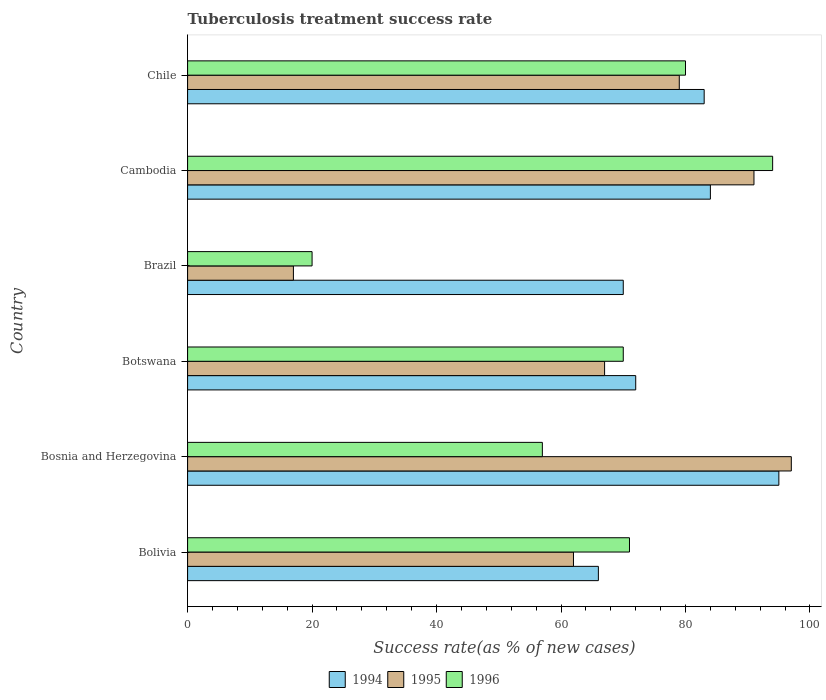How many different coloured bars are there?
Offer a very short reply. 3. How many groups of bars are there?
Offer a terse response. 6. Are the number of bars on each tick of the Y-axis equal?
Keep it short and to the point. Yes. What is the label of the 2nd group of bars from the top?
Offer a very short reply. Cambodia. In how many cases, is the number of bars for a given country not equal to the number of legend labels?
Provide a short and direct response. 0. What is the tuberculosis treatment success rate in 1996 in Cambodia?
Offer a very short reply. 94. Across all countries, what is the maximum tuberculosis treatment success rate in 1995?
Make the answer very short. 97. Across all countries, what is the minimum tuberculosis treatment success rate in 1995?
Ensure brevity in your answer.  17. In which country was the tuberculosis treatment success rate in 1995 maximum?
Your answer should be compact. Bosnia and Herzegovina. In which country was the tuberculosis treatment success rate in 1994 minimum?
Your response must be concise. Bolivia. What is the total tuberculosis treatment success rate in 1995 in the graph?
Keep it short and to the point. 413. What is the difference between the tuberculosis treatment success rate in 1996 in Brazil and that in Chile?
Offer a very short reply. -60. What is the difference between the tuberculosis treatment success rate in 1996 in Bolivia and the tuberculosis treatment success rate in 1995 in Chile?
Offer a terse response. -8. What is the average tuberculosis treatment success rate in 1994 per country?
Your answer should be very brief. 78.33. What is the difference between the tuberculosis treatment success rate in 1994 and tuberculosis treatment success rate in 1996 in Bolivia?
Provide a succinct answer. -5. In how many countries, is the tuberculosis treatment success rate in 1994 greater than 52 %?
Your response must be concise. 6. What is the ratio of the tuberculosis treatment success rate in 1994 in Botswana to that in Brazil?
Give a very brief answer. 1.03. Is the tuberculosis treatment success rate in 1994 in Bosnia and Herzegovina less than that in Botswana?
Make the answer very short. No. Is the difference between the tuberculosis treatment success rate in 1994 in Botswana and Brazil greater than the difference between the tuberculosis treatment success rate in 1996 in Botswana and Brazil?
Your answer should be very brief. No. Is the sum of the tuberculosis treatment success rate in 1995 in Brazil and Chile greater than the maximum tuberculosis treatment success rate in 1996 across all countries?
Your response must be concise. Yes. What does the 1st bar from the top in Brazil represents?
Offer a very short reply. 1996. What does the 3rd bar from the bottom in Bolivia represents?
Offer a terse response. 1996. How many bars are there?
Provide a succinct answer. 18. Are the values on the major ticks of X-axis written in scientific E-notation?
Provide a succinct answer. No. What is the title of the graph?
Offer a very short reply. Tuberculosis treatment success rate. Does "2002" appear as one of the legend labels in the graph?
Keep it short and to the point. No. What is the label or title of the X-axis?
Your response must be concise. Success rate(as % of new cases). What is the Success rate(as % of new cases) of 1994 in Bolivia?
Your answer should be compact. 66. What is the Success rate(as % of new cases) in 1995 in Bolivia?
Provide a short and direct response. 62. What is the Success rate(as % of new cases) in 1994 in Bosnia and Herzegovina?
Your answer should be compact. 95. What is the Success rate(as % of new cases) of 1995 in Bosnia and Herzegovina?
Provide a succinct answer. 97. What is the Success rate(as % of new cases) in 1996 in Botswana?
Offer a terse response. 70. What is the Success rate(as % of new cases) of 1995 in Brazil?
Give a very brief answer. 17. What is the Success rate(as % of new cases) of 1996 in Brazil?
Ensure brevity in your answer.  20. What is the Success rate(as % of new cases) of 1995 in Cambodia?
Provide a short and direct response. 91. What is the Success rate(as % of new cases) in 1996 in Cambodia?
Give a very brief answer. 94. What is the Success rate(as % of new cases) of 1994 in Chile?
Provide a succinct answer. 83. What is the Success rate(as % of new cases) of 1995 in Chile?
Your answer should be compact. 79. What is the Success rate(as % of new cases) of 1996 in Chile?
Your answer should be compact. 80. Across all countries, what is the maximum Success rate(as % of new cases) of 1994?
Ensure brevity in your answer.  95. Across all countries, what is the maximum Success rate(as % of new cases) of 1995?
Offer a very short reply. 97. Across all countries, what is the maximum Success rate(as % of new cases) in 1996?
Give a very brief answer. 94. Across all countries, what is the minimum Success rate(as % of new cases) in 1995?
Make the answer very short. 17. What is the total Success rate(as % of new cases) in 1994 in the graph?
Give a very brief answer. 470. What is the total Success rate(as % of new cases) of 1995 in the graph?
Provide a short and direct response. 413. What is the total Success rate(as % of new cases) of 1996 in the graph?
Your answer should be very brief. 392. What is the difference between the Success rate(as % of new cases) in 1994 in Bolivia and that in Bosnia and Herzegovina?
Your answer should be very brief. -29. What is the difference between the Success rate(as % of new cases) of 1995 in Bolivia and that in Bosnia and Herzegovina?
Your response must be concise. -35. What is the difference between the Success rate(as % of new cases) in 1995 in Bolivia and that in Brazil?
Your answer should be compact. 45. What is the difference between the Success rate(as % of new cases) of 1996 in Bolivia and that in Brazil?
Offer a very short reply. 51. What is the difference between the Success rate(as % of new cases) of 1996 in Bolivia and that in Cambodia?
Your answer should be compact. -23. What is the difference between the Success rate(as % of new cases) of 1996 in Bolivia and that in Chile?
Provide a short and direct response. -9. What is the difference between the Success rate(as % of new cases) of 1995 in Bosnia and Herzegovina and that in Botswana?
Your response must be concise. 30. What is the difference between the Success rate(as % of new cases) of 1994 in Bosnia and Herzegovina and that in Brazil?
Make the answer very short. 25. What is the difference between the Success rate(as % of new cases) of 1995 in Bosnia and Herzegovina and that in Brazil?
Make the answer very short. 80. What is the difference between the Success rate(as % of new cases) of 1994 in Bosnia and Herzegovina and that in Cambodia?
Your answer should be very brief. 11. What is the difference between the Success rate(as % of new cases) of 1996 in Bosnia and Herzegovina and that in Cambodia?
Your response must be concise. -37. What is the difference between the Success rate(as % of new cases) in 1994 in Bosnia and Herzegovina and that in Chile?
Provide a short and direct response. 12. What is the difference between the Success rate(as % of new cases) of 1995 in Bosnia and Herzegovina and that in Chile?
Your answer should be compact. 18. What is the difference between the Success rate(as % of new cases) in 1996 in Bosnia and Herzegovina and that in Chile?
Offer a terse response. -23. What is the difference between the Success rate(as % of new cases) in 1995 in Botswana and that in Brazil?
Offer a very short reply. 50. What is the difference between the Success rate(as % of new cases) of 1995 in Botswana and that in Cambodia?
Make the answer very short. -24. What is the difference between the Success rate(as % of new cases) in 1996 in Botswana and that in Cambodia?
Keep it short and to the point. -24. What is the difference between the Success rate(as % of new cases) in 1994 in Botswana and that in Chile?
Keep it short and to the point. -11. What is the difference between the Success rate(as % of new cases) in 1995 in Botswana and that in Chile?
Ensure brevity in your answer.  -12. What is the difference between the Success rate(as % of new cases) in 1994 in Brazil and that in Cambodia?
Your response must be concise. -14. What is the difference between the Success rate(as % of new cases) in 1995 in Brazil and that in Cambodia?
Make the answer very short. -74. What is the difference between the Success rate(as % of new cases) in 1996 in Brazil and that in Cambodia?
Offer a very short reply. -74. What is the difference between the Success rate(as % of new cases) in 1995 in Brazil and that in Chile?
Give a very brief answer. -62. What is the difference between the Success rate(as % of new cases) of 1996 in Brazil and that in Chile?
Provide a short and direct response. -60. What is the difference between the Success rate(as % of new cases) in 1996 in Cambodia and that in Chile?
Ensure brevity in your answer.  14. What is the difference between the Success rate(as % of new cases) of 1994 in Bolivia and the Success rate(as % of new cases) of 1995 in Bosnia and Herzegovina?
Keep it short and to the point. -31. What is the difference between the Success rate(as % of new cases) in 1994 in Bolivia and the Success rate(as % of new cases) in 1996 in Bosnia and Herzegovina?
Provide a short and direct response. 9. What is the difference between the Success rate(as % of new cases) of 1995 in Bolivia and the Success rate(as % of new cases) of 1996 in Bosnia and Herzegovina?
Ensure brevity in your answer.  5. What is the difference between the Success rate(as % of new cases) in 1994 in Bolivia and the Success rate(as % of new cases) in 1995 in Botswana?
Make the answer very short. -1. What is the difference between the Success rate(as % of new cases) of 1995 in Bolivia and the Success rate(as % of new cases) of 1996 in Botswana?
Provide a short and direct response. -8. What is the difference between the Success rate(as % of new cases) in 1994 in Bolivia and the Success rate(as % of new cases) in 1995 in Brazil?
Provide a succinct answer. 49. What is the difference between the Success rate(as % of new cases) in 1995 in Bolivia and the Success rate(as % of new cases) in 1996 in Brazil?
Ensure brevity in your answer.  42. What is the difference between the Success rate(as % of new cases) in 1994 in Bolivia and the Success rate(as % of new cases) in 1996 in Cambodia?
Ensure brevity in your answer.  -28. What is the difference between the Success rate(as % of new cases) in 1995 in Bolivia and the Success rate(as % of new cases) in 1996 in Cambodia?
Ensure brevity in your answer.  -32. What is the difference between the Success rate(as % of new cases) of 1994 in Bolivia and the Success rate(as % of new cases) of 1995 in Chile?
Ensure brevity in your answer.  -13. What is the difference between the Success rate(as % of new cases) in 1994 in Bosnia and Herzegovina and the Success rate(as % of new cases) in 1996 in Brazil?
Make the answer very short. 75. What is the difference between the Success rate(as % of new cases) in 1995 in Bosnia and Herzegovina and the Success rate(as % of new cases) in 1996 in Brazil?
Provide a short and direct response. 77. What is the difference between the Success rate(as % of new cases) in 1994 in Bosnia and Herzegovina and the Success rate(as % of new cases) in 1995 in Cambodia?
Offer a terse response. 4. What is the difference between the Success rate(as % of new cases) in 1994 in Bosnia and Herzegovina and the Success rate(as % of new cases) in 1996 in Cambodia?
Your answer should be compact. 1. What is the difference between the Success rate(as % of new cases) in 1995 in Bosnia and Herzegovina and the Success rate(as % of new cases) in 1996 in Cambodia?
Give a very brief answer. 3. What is the difference between the Success rate(as % of new cases) of 1994 in Bosnia and Herzegovina and the Success rate(as % of new cases) of 1995 in Chile?
Make the answer very short. 16. What is the difference between the Success rate(as % of new cases) of 1994 in Bosnia and Herzegovina and the Success rate(as % of new cases) of 1996 in Chile?
Keep it short and to the point. 15. What is the difference between the Success rate(as % of new cases) of 1995 in Bosnia and Herzegovina and the Success rate(as % of new cases) of 1996 in Chile?
Give a very brief answer. 17. What is the difference between the Success rate(as % of new cases) in 1994 in Botswana and the Success rate(as % of new cases) in 1996 in Brazil?
Offer a terse response. 52. What is the difference between the Success rate(as % of new cases) of 1995 in Botswana and the Success rate(as % of new cases) of 1996 in Brazil?
Your response must be concise. 47. What is the difference between the Success rate(as % of new cases) of 1994 in Botswana and the Success rate(as % of new cases) of 1995 in Cambodia?
Provide a short and direct response. -19. What is the difference between the Success rate(as % of new cases) in 1994 in Botswana and the Success rate(as % of new cases) in 1996 in Cambodia?
Your answer should be compact. -22. What is the difference between the Success rate(as % of new cases) in 1995 in Botswana and the Success rate(as % of new cases) in 1996 in Cambodia?
Offer a very short reply. -27. What is the difference between the Success rate(as % of new cases) in 1995 in Botswana and the Success rate(as % of new cases) in 1996 in Chile?
Offer a terse response. -13. What is the difference between the Success rate(as % of new cases) in 1994 in Brazil and the Success rate(as % of new cases) in 1995 in Cambodia?
Provide a short and direct response. -21. What is the difference between the Success rate(as % of new cases) of 1995 in Brazil and the Success rate(as % of new cases) of 1996 in Cambodia?
Your answer should be compact. -77. What is the difference between the Success rate(as % of new cases) of 1994 in Brazil and the Success rate(as % of new cases) of 1995 in Chile?
Offer a very short reply. -9. What is the difference between the Success rate(as % of new cases) of 1995 in Brazil and the Success rate(as % of new cases) of 1996 in Chile?
Your answer should be compact. -63. What is the difference between the Success rate(as % of new cases) in 1994 in Cambodia and the Success rate(as % of new cases) in 1996 in Chile?
Provide a short and direct response. 4. What is the average Success rate(as % of new cases) in 1994 per country?
Ensure brevity in your answer.  78.33. What is the average Success rate(as % of new cases) of 1995 per country?
Provide a succinct answer. 68.83. What is the average Success rate(as % of new cases) of 1996 per country?
Provide a succinct answer. 65.33. What is the difference between the Success rate(as % of new cases) of 1994 and Success rate(as % of new cases) of 1996 in Bolivia?
Offer a terse response. -5. What is the difference between the Success rate(as % of new cases) in 1995 and Success rate(as % of new cases) in 1996 in Bolivia?
Your answer should be compact. -9. What is the difference between the Success rate(as % of new cases) in 1994 and Success rate(as % of new cases) in 1995 in Botswana?
Offer a terse response. 5. What is the difference between the Success rate(as % of new cases) in 1994 and Success rate(as % of new cases) in 1996 in Botswana?
Your response must be concise. 2. What is the difference between the Success rate(as % of new cases) of 1995 and Success rate(as % of new cases) of 1996 in Botswana?
Provide a short and direct response. -3. What is the difference between the Success rate(as % of new cases) in 1995 and Success rate(as % of new cases) in 1996 in Brazil?
Give a very brief answer. -3. What is the difference between the Success rate(as % of new cases) in 1994 and Success rate(as % of new cases) in 1996 in Cambodia?
Provide a succinct answer. -10. What is the difference between the Success rate(as % of new cases) in 1995 and Success rate(as % of new cases) in 1996 in Cambodia?
Your answer should be compact. -3. What is the difference between the Success rate(as % of new cases) of 1994 and Success rate(as % of new cases) of 1995 in Chile?
Your response must be concise. 4. What is the ratio of the Success rate(as % of new cases) in 1994 in Bolivia to that in Bosnia and Herzegovina?
Make the answer very short. 0.69. What is the ratio of the Success rate(as % of new cases) in 1995 in Bolivia to that in Bosnia and Herzegovina?
Offer a terse response. 0.64. What is the ratio of the Success rate(as % of new cases) of 1996 in Bolivia to that in Bosnia and Herzegovina?
Your answer should be compact. 1.25. What is the ratio of the Success rate(as % of new cases) in 1994 in Bolivia to that in Botswana?
Make the answer very short. 0.92. What is the ratio of the Success rate(as % of new cases) in 1995 in Bolivia to that in Botswana?
Your response must be concise. 0.93. What is the ratio of the Success rate(as % of new cases) in 1996 in Bolivia to that in Botswana?
Your response must be concise. 1.01. What is the ratio of the Success rate(as % of new cases) of 1994 in Bolivia to that in Brazil?
Your answer should be very brief. 0.94. What is the ratio of the Success rate(as % of new cases) of 1995 in Bolivia to that in Brazil?
Your response must be concise. 3.65. What is the ratio of the Success rate(as % of new cases) in 1996 in Bolivia to that in Brazil?
Offer a terse response. 3.55. What is the ratio of the Success rate(as % of new cases) in 1994 in Bolivia to that in Cambodia?
Offer a very short reply. 0.79. What is the ratio of the Success rate(as % of new cases) of 1995 in Bolivia to that in Cambodia?
Offer a very short reply. 0.68. What is the ratio of the Success rate(as % of new cases) of 1996 in Bolivia to that in Cambodia?
Make the answer very short. 0.76. What is the ratio of the Success rate(as % of new cases) in 1994 in Bolivia to that in Chile?
Keep it short and to the point. 0.8. What is the ratio of the Success rate(as % of new cases) in 1995 in Bolivia to that in Chile?
Provide a short and direct response. 0.78. What is the ratio of the Success rate(as % of new cases) of 1996 in Bolivia to that in Chile?
Your response must be concise. 0.89. What is the ratio of the Success rate(as % of new cases) in 1994 in Bosnia and Herzegovina to that in Botswana?
Your response must be concise. 1.32. What is the ratio of the Success rate(as % of new cases) of 1995 in Bosnia and Herzegovina to that in Botswana?
Provide a succinct answer. 1.45. What is the ratio of the Success rate(as % of new cases) in 1996 in Bosnia and Herzegovina to that in Botswana?
Provide a succinct answer. 0.81. What is the ratio of the Success rate(as % of new cases) in 1994 in Bosnia and Herzegovina to that in Brazil?
Ensure brevity in your answer.  1.36. What is the ratio of the Success rate(as % of new cases) in 1995 in Bosnia and Herzegovina to that in Brazil?
Make the answer very short. 5.71. What is the ratio of the Success rate(as % of new cases) in 1996 in Bosnia and Herzegovina to that in Brazil?
Make the answer very short. 2.85. What is the ratio of the Success rate(as % of new cases) of 1994 in Bosnia and Herzegovina to that in Cambodia?
Provide a succinct answer. 1.13. What is the ratio of the Success rate(as % of new cases) in 1995 in Bosnia and Herzegovina to that in Cambodia?
Offer a very short reply. 1.07. What is the ratio of the Success rate(as % of new cases) of 1996 in Bosnia and Herzegovina to that in Cambodia?
Keep it short and to the point. 0.61. What is the ratio of the Success rate(as % of new cases) in 1994 in Bosnia and Herzegovina to that in Chile?
Keep it short and to the point. 1.14. What is the ratio of the Success rate(as % of new cases) in 1995 in Bosnia and Herzegovina to that in Chile?
Offer a very short reply. 1.23. What is the ratio of the Success rate(as % of new cases) of 1996 in Bosnia and Herzegovina to that in Chile?
Provide a short and direct response. 0.71. What is the ratio of the Success rate(as % of new cases) of 1994 in Botswana to that in Brazil?
Provide a short and direct response. 1.03. What is the ratio of the Success rate(as % of new cases) of 1995 in Botswana to that in Brazil?
Keep it short and to the point. 3.94. What is the ratio of the Success rate(as % of new cases) in 1995 in Botswana to that in Cambodia?
Offer a terse response. 0.74. What is the ratio of the Success rate(as % of new cases) of 1996 in Botswana to that in Cambodia?
Your answer should be compact. 0.74. What is the ratio of the Success rate(as % of new cases) of 1994 in Botswana to that in Chile?
Your answer should be very brief. 0.87. What is the ratio of the Success rate(as % of new cases) in 1995 in Botswana to that in Chile?
Offer a very short reply. 0.85. What is the ratio of the Success rate(as % of new cases) of 1996 in Botswana to that in Chile?
Ensure brevity in your answer.  0.88. What is the ratio of the Success rate(as % of new cases) in 1995 in Brazil to that in Cambodia?
Give a very brief answer. 0.19. What is the ratio of the Success rate(as % of new cases) in 1996 in Brazil to that in Cambodia?
Ensure brevity in your answer.  0.21. What is the ratio of the Success rate(as % of new cases) in 1994 in Brazil to that in Chile?
Provide a short and direct response. 0.84. What is the ratio of the Success rate(as % of new cases) of 1995 in Brazil to that in Chile?
Provide a succinct answer. 0.22. What is the ratio of the Success rate(as % of new cases) in 1996 in Brazil to that in Chile?
Your answer should be very brief. 0.25. What is the ratio of the Success rate(as % of new cases) in 1995 in Cambodia to that in Chile?
Provide a succinct answer. 1.15. What is the ratio of the Success rate(as % of new cases) of 1996 in Cambodia to that in Chile?
Offer a terse response. 1.18. What is the difference between the highest and the second highest Success rate(as % of new cases) in 1995?
Your answer should be very brief. 6. What is the difference between the highest and the second highest Success rate(as % of new cases) in 1996?
Offer a terse response. 14. What is the difference between the highest and the lowest Success rate(as % of new cases) in 1994?
Give a very brief answer. 29. What is the difference between the highest and the lowest Success rate(as % of new cases) of 1995?
Provide a succinct answer. 80. 